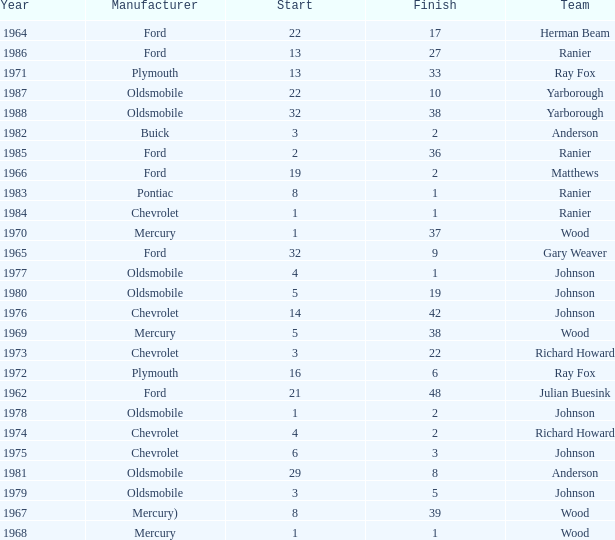Who was the maufacturer of the vehicle during the race where Cale Yarborough started at 19 and finished earlier than 42? Ford. 